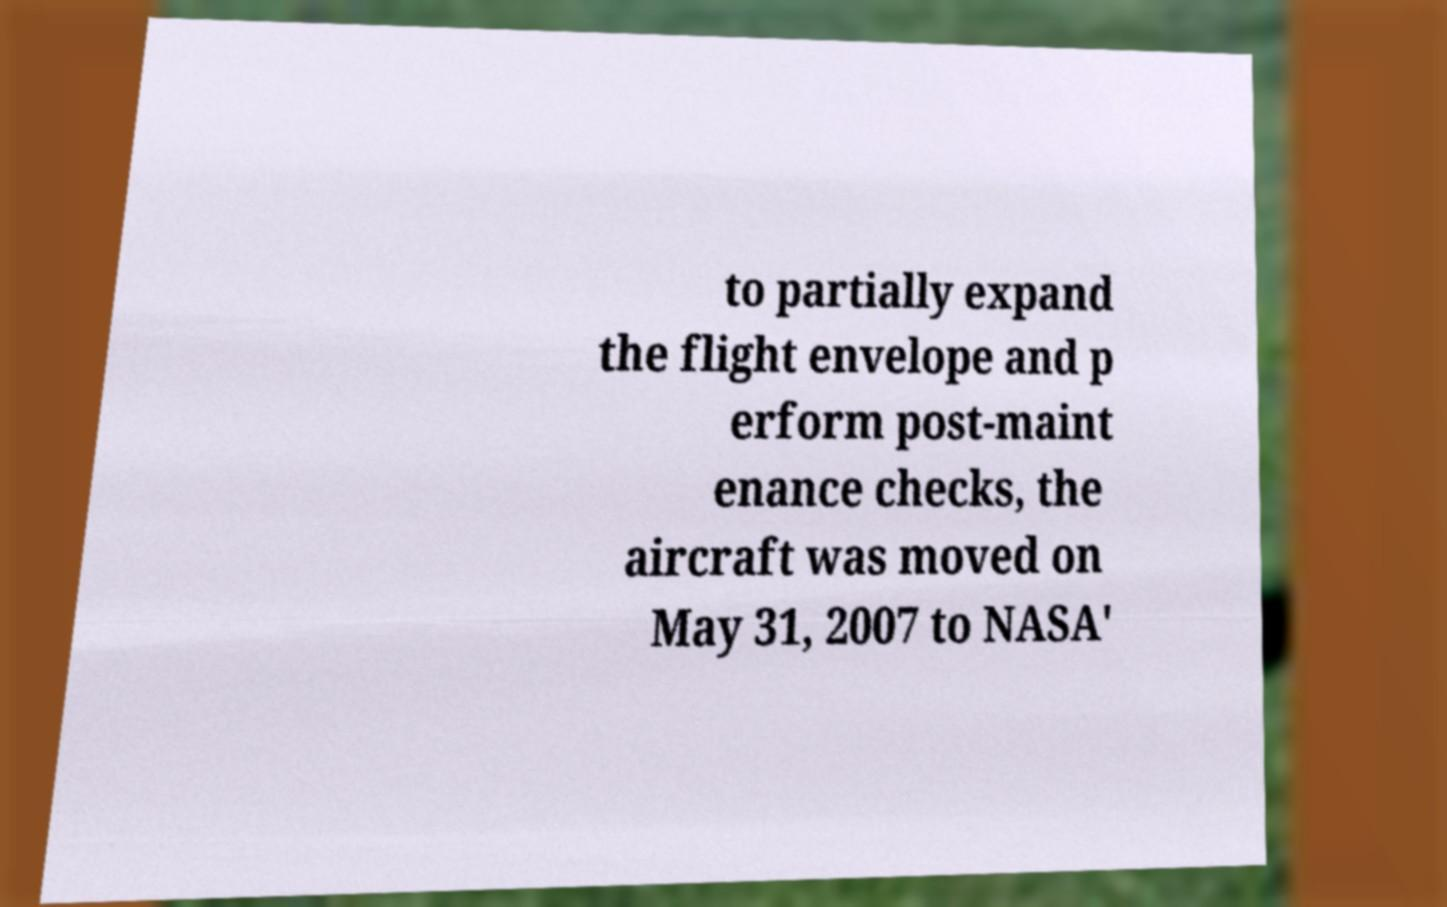Could you assist in decoding the text presented in this image and type it out clearly? to partially expand the flight envelope and p erform post-maint enance checks, the aircraft was moved on May 31, 2007 to NASA' 